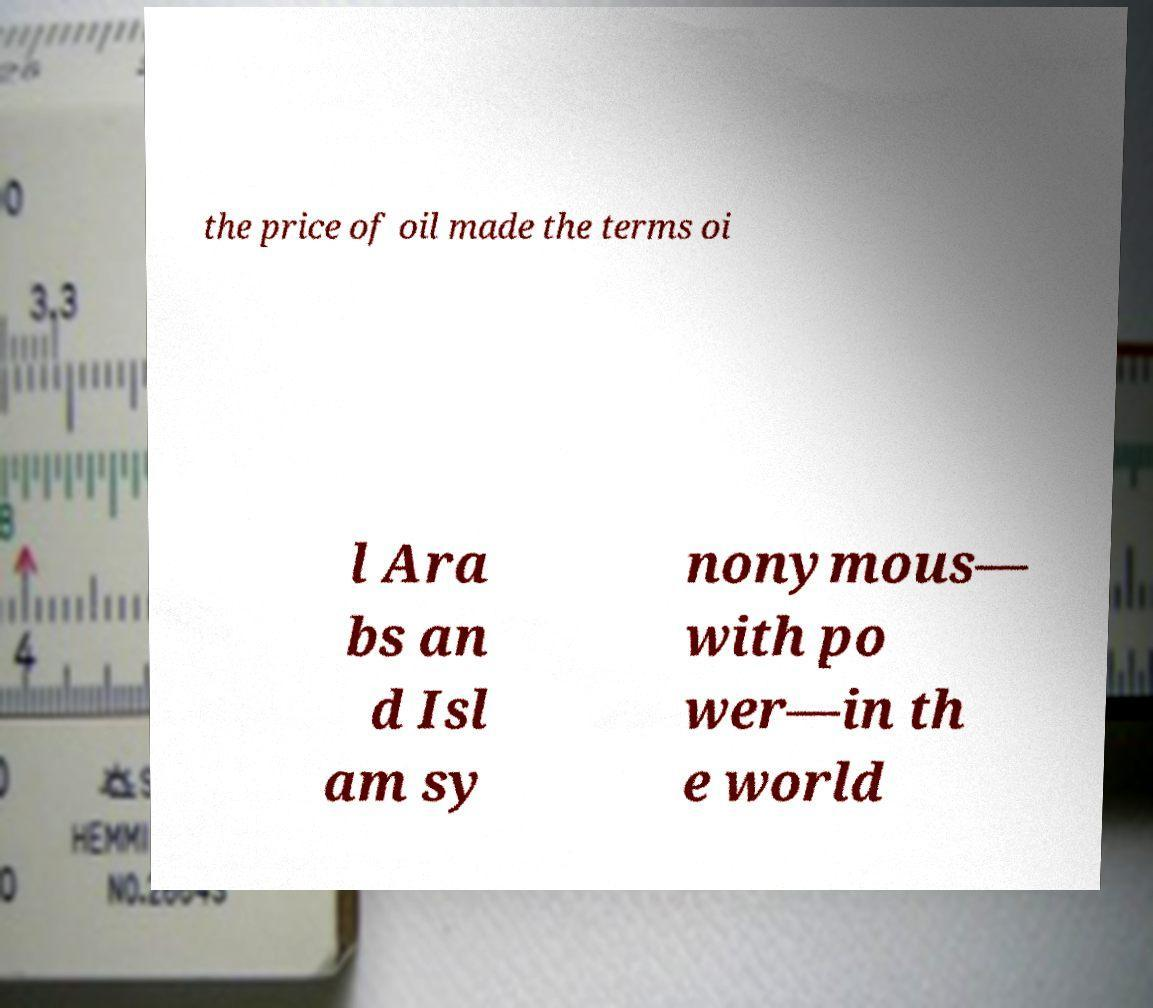Could you extract and type out the text from this image? the price of oil made the terms oi l Ara bs an d Isl am sy nonymous— with po wer—in th e world 